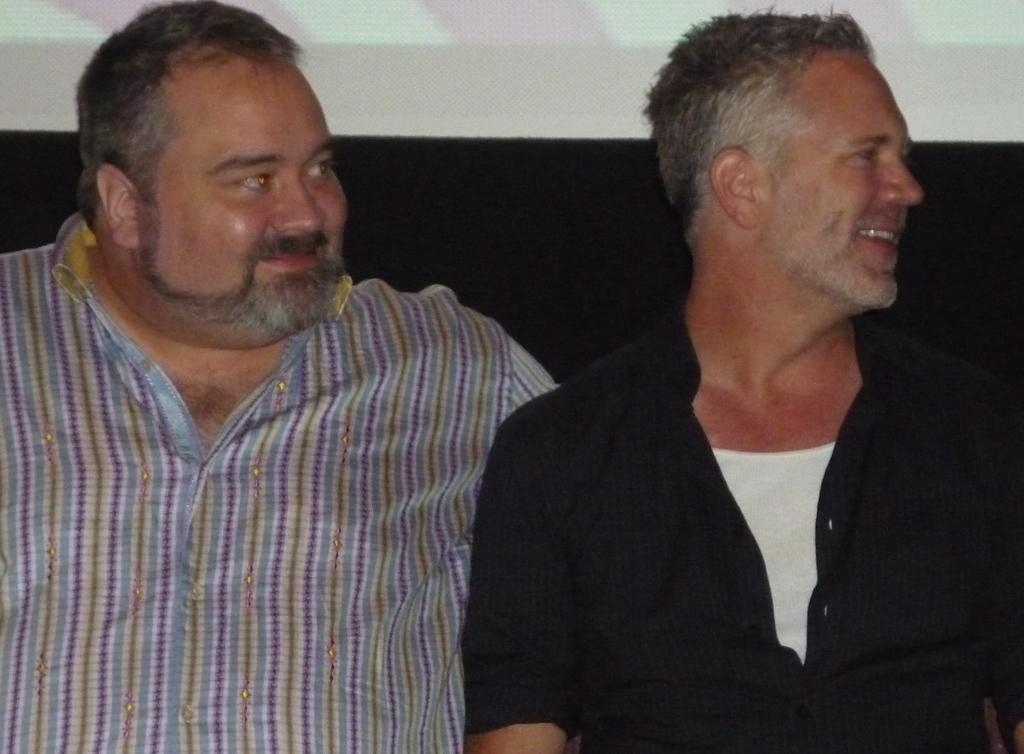What is the main subject of the image? The main subject of the image is a speaker. What is the speaker doing in the image? The speaker is sitting in the image. What expression does the speaker have? The speaker is smiling in the image. What type of quince is the speaker holding in the image? There is no quince present in the image; the speaker is not holding any fruit. 